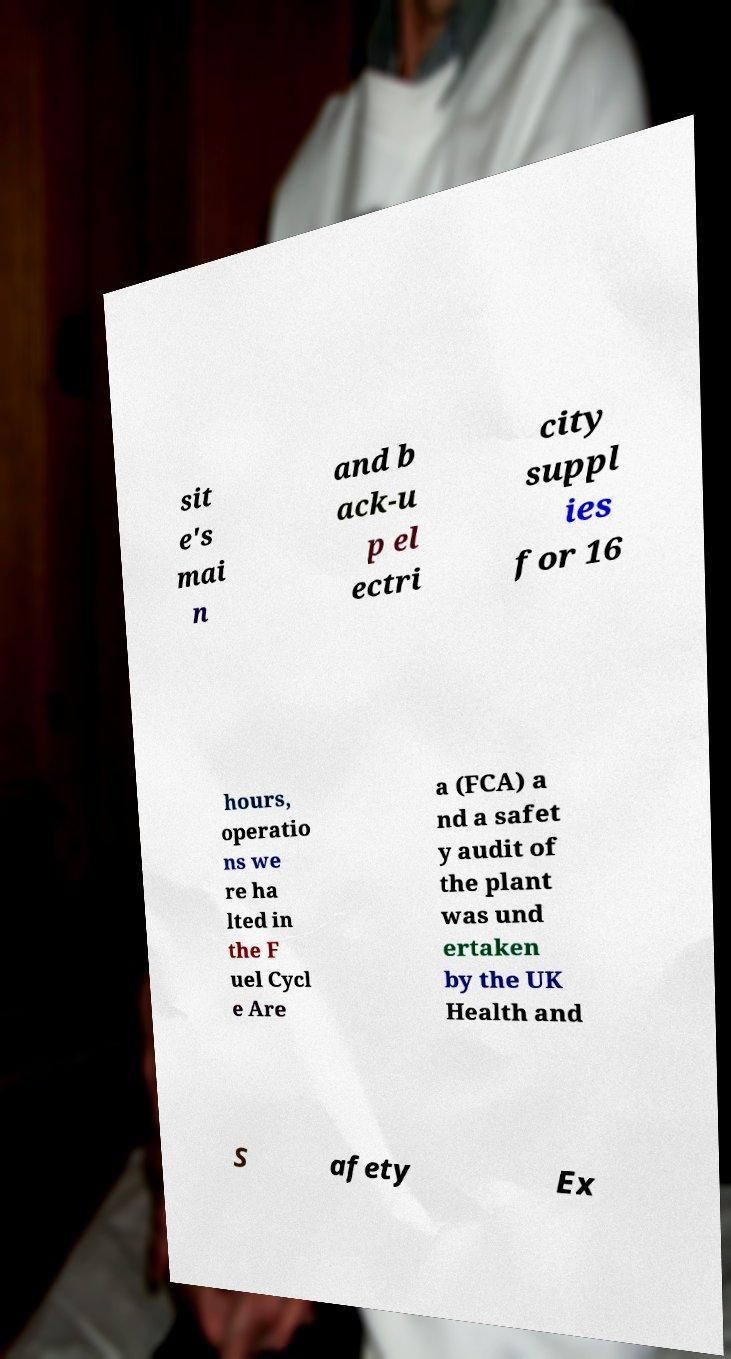Could you assist in decoding the text presented in this image and type it out clearly? sit e's mai n and b ack-u p el ectri city suppl ies for 16 hours, operatio ns we re ha lted in the F uel Cycl e Are a (FCA) a nd a safet y audit of the plant was und ertaken by the UK Health and S afety Ex 